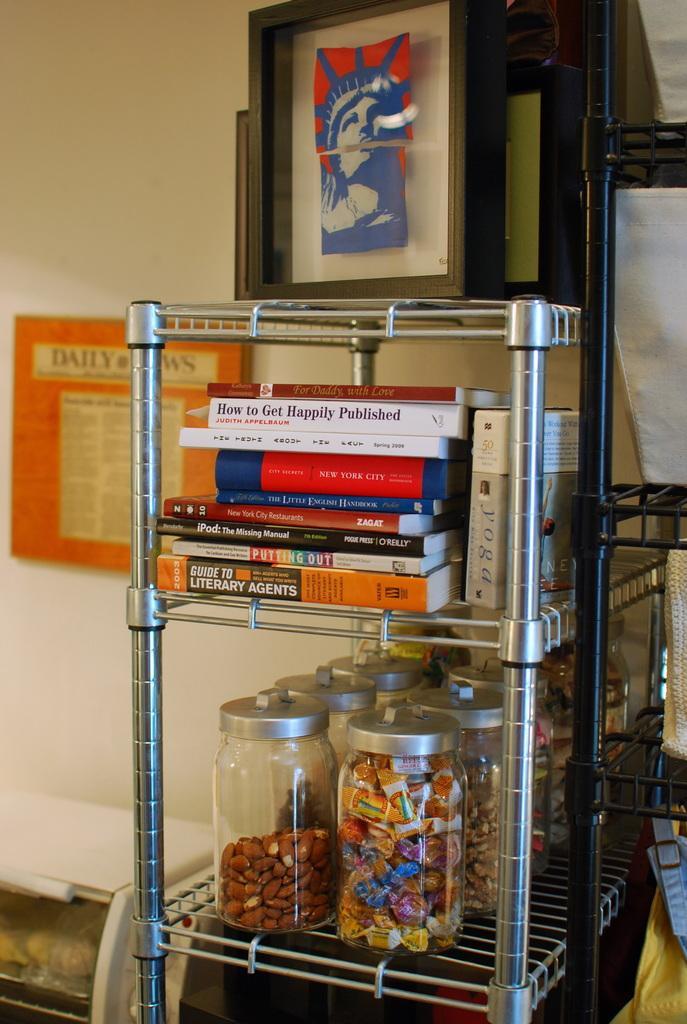In one or two sentences, can you explain what this image depicts? In this image we can see two strands and where we can see some books and jars with food items. There are some other objects on the stands and we can see the wall with a poster and some text on it. We can also see some photo frames on the stand. 